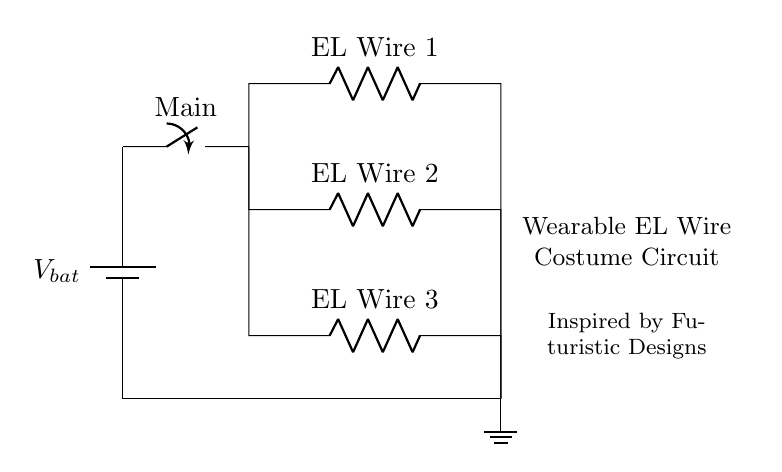What type of circuit is shown? The circuit is a parallel circuit because all the components (EL wires) are connected across the same voltage source independently, allowing each to receive the same voltage.
Answer: Parallel How many resistors are in the circuit? There are three resistors in the circuit, each representing one EL wire, connected in parallel.
Answer: Three What is the role of the main switch? The main switch controls the flow of electricity through the circuit, allowing the user to turn all EL wires on or off simultaneously.
Answer: Control What is the voltage across each EL wire? Each EL wire has the same voltage across it, which is equal to the battery voltage, denoted as V_bat.
Answer: V_bat If one EL wire fails, what happens to the others? The other EL wires will continue to function normally because they are in parallel, and the failure does not interrupt the current flow in the remaining branches.
Answer: Continue functioning What would happen if the battery voltage is increased? Increasing the battery voltage would raise the voltage across each EL wire, resulting in brighter illumination for each wire. However, it could also exceed the rated voltage for the wires, risking damage.
Answer: Brighten 